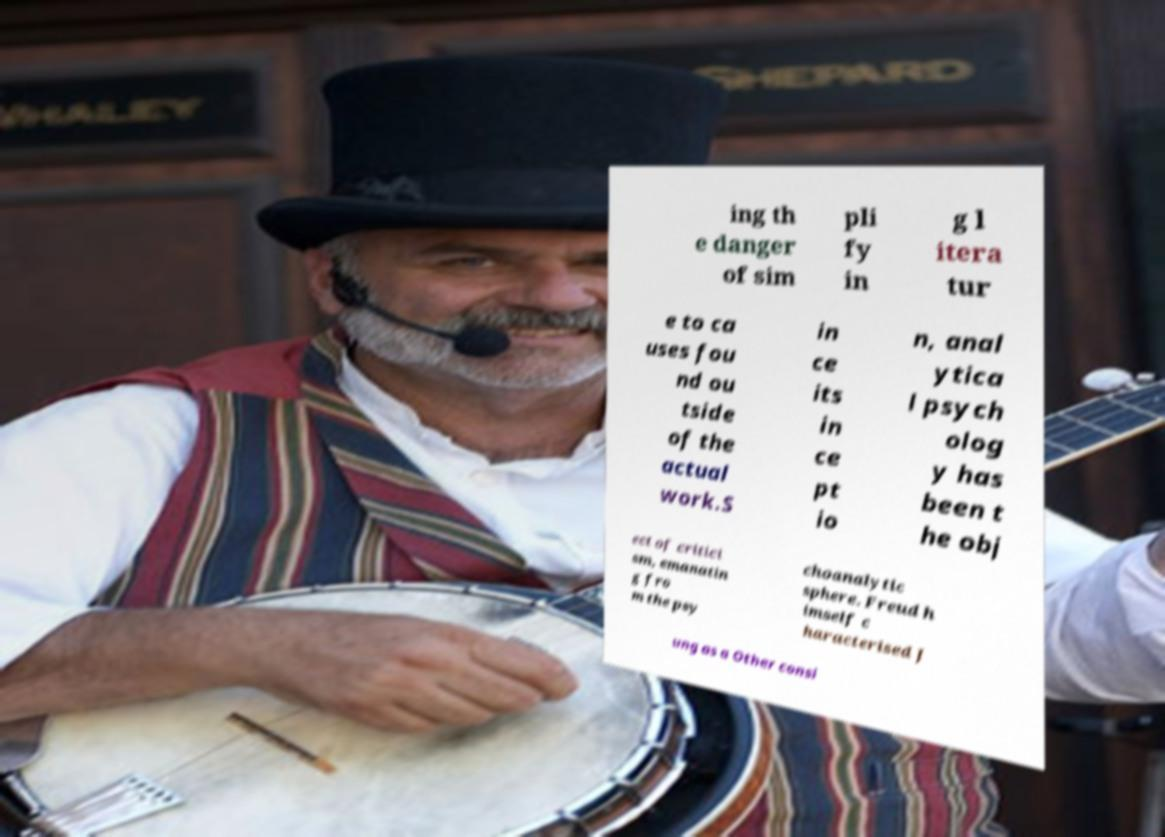Please identify and transcribe the text found in this image. ing th e danger of sim pli fy in g l itera tur e to ca uses fou nd ou tside of the actual work.S in ce its in ce pt io n, anal ytica l psych olog y has been t he obj ect of critici sm, emanatin g fro m the psy choanalytic sphere. Freud h imself c haracterised J ung as a Other consi 